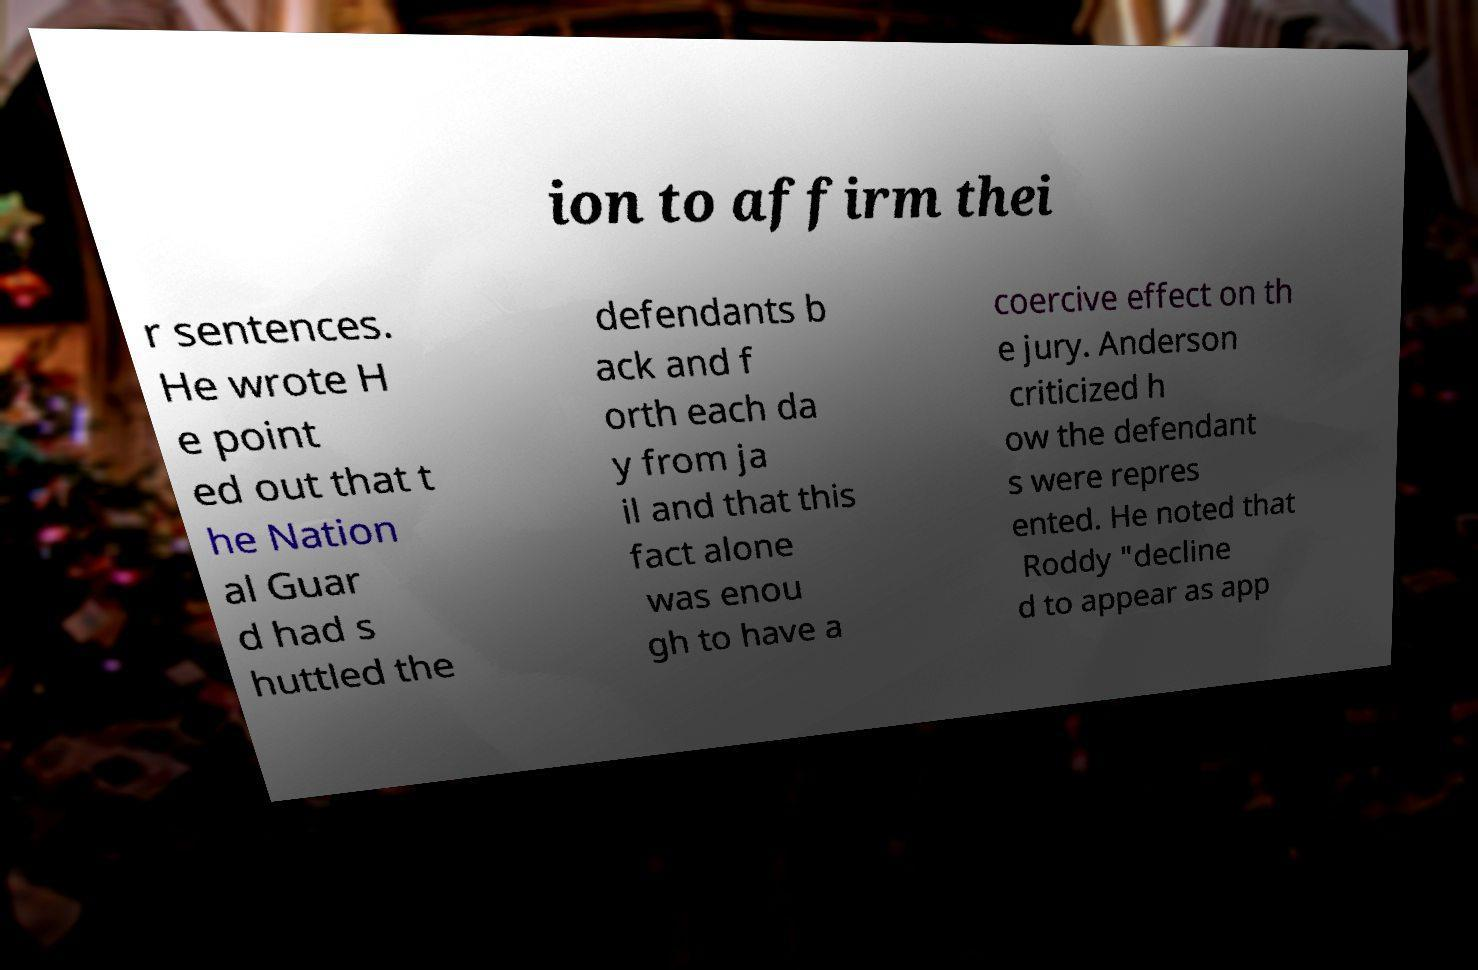Can you accurately transcribe the text from the provided image for me? ion to affirm thei r sentences. He wrote H e point ed out that t he Nation al Guar d had s huttled the defendants b ack and f orth each da y from ja il and that this fact alone was enou gh to have a coercive effect on th e jury. Anderson criticized h ow the defendant s were repres ented. He noted that Roddy "decline d to appear as app 